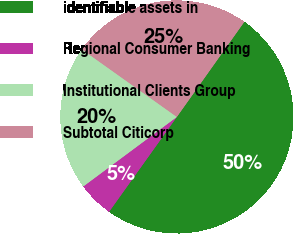Convert chart to OTSL. <chart><loc_0><loc_0><loc_500><loc_500><pie_chart><fcel>identifiable assets in<fcel>Regional Consumer Banking<fcel>Institutional Clients Group<fcel>Subtotal Citicorp<nl><fcel>50.05%<fcel>4.96%<fcel>20.01%<fcel>24.98%<nl></chart> 